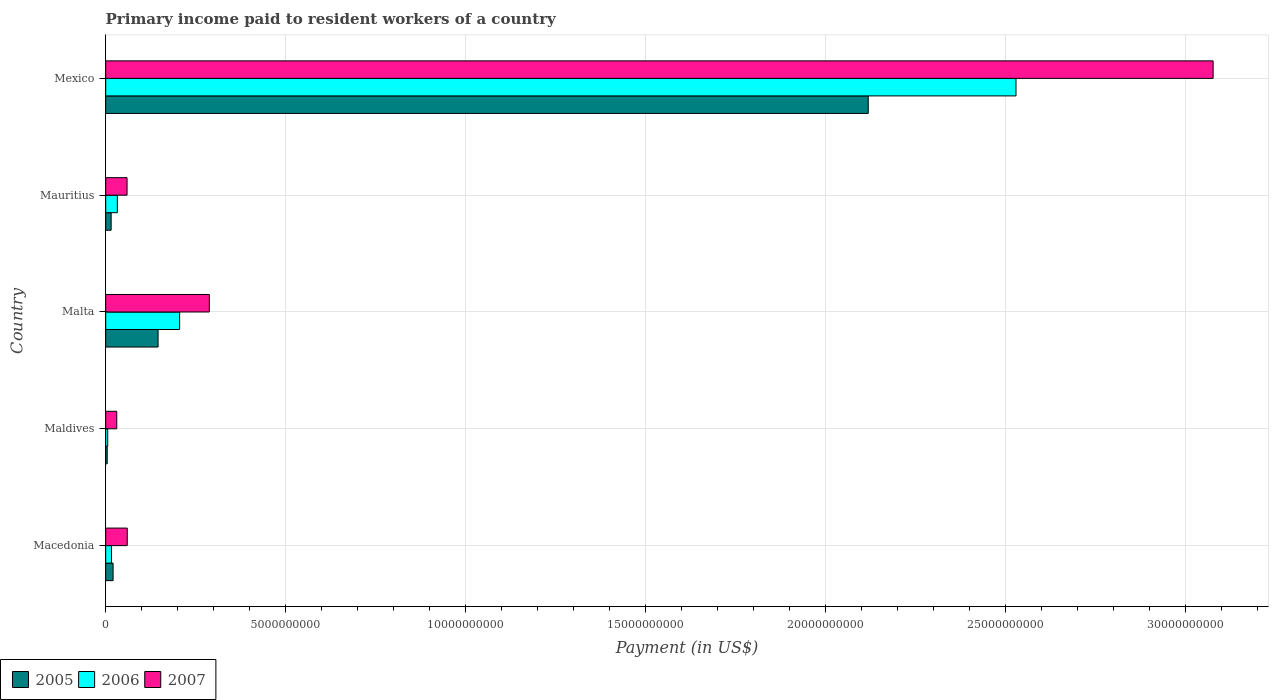How many different coloured bars are there?
Keep it short and to the point. 3. How many groups of bars are there?
Ensure brevity in your answer.  5. Are the number of bars per tick equal to the number of legend labels?
Provide a short and direct response. Yes. Are the number of bars on each tick of the Y-axis equal?
Give a very brief answer. Yes. How many bars are there on the 2nd tick from the top?
Your answer should be compact. 3. How many bars are there on the 3rd tick from the bottom?
Ensure brevity in your answer.  3. What is the label of the 4th group of bars from the top?
Provide a succinct answer. Maldives. What is the amount paid to workers in 2006 in Maldives?
Give a very brief answer. 5.63e+07. Across all countries, what is the maximum amount paid to workers in 2006?
Make the answer very short. 2.53e+1. Across all countries, what is the minimum amount paid to workers in 2007?
Your answer should be compact. 3.07e+08. In which country was the amount paid to workers in 2006 minimum?
Provide a succinct answer. Maldives. What is the total amount paid to workers in 2006 in the graph?
Provide a succinct answer. 2.79e+1. What is the difference between the amount paid to workers in 2006 in Malta and that in Mauritius?
Give a very brief answer. 1.73e+09. What is the difference between the amount paid to workers in 2005 in Malta and the amount paid to workers in 2007 in Maldives?
Provide a short and direct response. 1.15e+09. What is the average amount paid to workers in 2005 per country?
Provide a short and direct response. 4.61e+09. What is the difference between the amount paid to workers in 2007 and amount paid to workers in 2006 in Malta?
Your answer should be compact. 8.25e+08. In how many countries, is the amount paid to workers in 2005 greater than 4000000000 US$?
Ensure brevity in your answer.  1. What is the ratio of the amount paid to workers in 2007 in Macedonia to that in Malta?
Give a very brief answer. 0.21. Is the difference between the amount paid to workers in 2007 in Malta and Mexico greater than the difference between the amount paid to workers in 2006 in Malta and Mexico?
Provide a short and direct response. No. What is the difference between the highest and the second highest amount paid to workers in 2006?
Your response must be concise. 2.32e+1. What is the difference between the highest and the lowest amount paid to workers in 2006?
Keep it short and to the point. 2.52e+1. What does the 3rd bar from the bottom in Macedonia represents?
Provide a short and direct response. 2007. Are all the bars in the graph horizontal?
Provide a short and direct response. Yes. How many countries are there in the graph?
Keep it short and to the point. 5. What is the difference between two consecutive major ticks on the X-axis?
Offer a very short reply. 5.00e+09. Does the graph contain grids?
Your answer should be compact. Yes. Where does the legend appear in the graph?
Offer a terse response. Bottom left. How are the legend labels stacked?
Offer a terse response. Horizontal. What is the title of the graph?
Provide a succinct answer. Primary income paid to resident workers of a country. What is the label or title of the X-axis?
Offer a terse response. Payment (in US$). What is the Payment (in US$) of 2005 in Macedonia?
Provide a short and direct response. 2.06e+08. What is the Payment (in US$) of 2006 in Macedonia?
Your answer should be compact. 1.60e+08. What is the Payment (in US$) of 2007 in Macedonia?
Your response must be concise. 5.99e+08. What is the Payment (in US$) in 2005 in Maldives?
Offer a very short reply. 4.18e+07. What is the Payment (in US$) of 2006 in Maldives?
Provide a short and direct response. 5.63e+07. What is the Payment (in US$) of 2007 in Maldives?
Ensure brevity in your answer.  3.07e+08. What is the Payment (in US$) in 2005 in Malta?
Offer a very short reply. 1.45e+09. What is the Payment (in US$) in 2006 in Malta?
Ensure brevity in your answer.  2.05e+09. What is the Payment (in US$) in 2007 in Malta?
Make the answer very short. 2.88e+09. What is the Payment (in US$) in 2005 in Mauritius?
Make the answer very short. 1.51e+08. What is the Payment (in US$) in 2006 in Mauritius?
Make the answer very short. 3.24e+08. What is the Payment (in US$) in 2007 in Mauritius?
Provide a succinct answer. 5.93e+08. What is the Payment (in US$) of 2005 in Mexico?
Your answer should be compact. 2.12e+1. What is the Payment (in US$) of 2006 in Mexico?
Keep it short and to the point. 2.53e+1. What is the Payment (in US$) of 2007 in Mexico?
Your answer should be compact. 3.08e+1. Across all countries, what is the maximum Payment (in US$) in 2005?
Provide a succinct answer. 2.12e+1. Across all countries, what is the maximum Payment (in US$) in 2006?
Offer a terse response. 2.53e+1. Across all countries, what is the maximum Payment (in US$) in 2007?
Give a very brief answer. 3.08e+1. Across all countries, what is the minimum Payment (in US$) in 2005?
Give a very brief answer. 4.18e+07. Across all countries, what is the minimum Payment (in US$) in 2006?
Give a very brief answer. 5.63e+07. Across all countries, what is the minimum Payment (in US$) of 2007?
Your answer should be very brief. 3.07e+08. What is the total Payment (in US$) in 2005 in the graph?
Your answer should be very brief. 2.30e+1. What is the total Payment (in US$) in 2006 in the graph?
Your response must be concise. 2.79e+1. What is the total Payment (in US$) of 2007 in the graph?
Ensure brevity in your answer.  3.51e+1. What is the difference between the Payment (in US$) of 2005 in Macedonia and that in Maldives?
Provide a succinct answer. 1.64e+08. What is the difference between the Payment (in US$) of 2006 in Macedonia and that in Maldives?
Make the answer very short. 1.04e+08. What is the difference between the Payment (in US$) of 2007 in Macedonia and that in Maldives?
Provide a short and direct response. 2.91e+08. What is the difference between the Payment (in US$) in 2005 in Macedonia and that in Malta?
Provide a short and direct response. -1.25e+09. What is the difference between the Payment (in US$) in 2006 in Macedonia and that in Malta?
Ensure brevity in your answer.  -1.89e+09. What is the difference between the Payment (in US$) of 2007 in Macedonia and that in Malta?
Offer a very short reply. -2.28e+09. What is the difference between the Payment (in US$) of 2005 in Macedonia and that in Mauritius?
Offer a terse response. 5.42e+07. What is the difference between the Payment (in US$) of 2006 in Macedonia and that in Mauritius?
Offer a very short reply. -1.64e+08. What is the difference between the Payment (in US$) in 2007 in Macedonia and that in Mauritius?
Keep it short and to the point. 5.27e+06. What is the difference between the Payment (in US$) of 2005 in Macedonia and that in Mexico?
Give a very brief answer. -2.10e+1. What is the difference between the Payment (in US$) in 2006 in Macedonia and that in Mexico?
Your answer should be compact. -2.51e+1. What is the difference between the Payment (in US$) of 2007 in Macedonia and that in Mexico?
Your response must be concise. -3.02e+1. What is the difference between the Payment (in US$) of 2005 in Maldives and that in Malta?
Offer a terse response. -1.41e+09. What is the difference between the Payment (in US$) of 2006 in Maldives and that in Malta?
Offer a terse response. -2.00e+09. What is the difference between the Payment (in US$) in 2007 in Maldives and that in Malta?
Keep it short and to the point. -2.57e+09. What is the difference between the Payment (in US$) in 2005 in Maldives and that in Mauritius?
Your answer should be compact. -1.10e+08. What is the difference between the Payment (in US$) of 2006 in Maldives and that in Mauritius?
Ensure brevity in your answer.  -2.68e+08. What is the difference between the Payment (in US$) of 2007 in Maldives and that in Mauritius?
Your answer should be very brief. -2.86e+08. What is the difference between the Payment (in US$) of 2005 in Maldives and that in Mexico?
Offer a terse response. -2.11e+1. What is the difference between the Payment (in US$) of 2006 in Maldives and that in Mexico?
Ensure brevity in your answer.  -2.52e+1. What is the difference between the Payment (in US$) of 2007 in Maldives and that in Mexico?
Offer a very short reply. -3.05e+1. What is the difference between the Payment (in US$) in 2005 in Malta and that in Mauritius?
Give a very brief answer. 1.30e+09. What is the difference between the Payment (in US$) of 2006 in Malta and that in Mauritius?
Your answer should be very brief. 1.73e+09. What is the difference between the Payment (in US$) of 2007 in Malta and that in Mauritius?
Make the answer very short. 2.29e+09. What is the difference between the Payment (in US$) of 2005 in Malta and that in Mexico?
Ensure brevity in your answer.  -1.97e+1. What is the difference between the Payment (in US$) of 2006 in Malta and that in Mexico?
Your answer should be very brief. -2.32e+1. What is the difference between the Payment (in US$) in 2007 in Malta and that in Mexico?
Offer a terse response. -2.79e+1. What is the difference between the Payment (in US$) in 2005 in Mauritius and that in Mexico?
Your response must be concise. -2.10e+1. What is the difference between the Payment (in US$) of 2006 in Mauritius and that in Mexico?
Keep it short and to the point. -2.50e+1. What is the difference between the Payment (in US$) of 2007 in Mauritius and that in Mexico?
Provide a succinct answer. -3.02e+1. What is the difference between the Payment (in US$) of 2005 in Macedonia and the Payment (in US$) of 2006 in Maldives?
Keep it short and to the point. 1.49e+08. What is the difference between the Payment (in US$) in 2005 in Macedonia and the Payment (in US$) in 2007 in Maldives?
Your response must be concise. -1.02e+08. What is the difference between the Payment (in US$) in 2006 in Macedonia and the Payment (in US$) in 2007 in Maldives?
Ensure brevity in your answer.  -1.47e+08. What is the difference between the Payment (in US$) of 2005 in Macedonia and the Payment (in US$) of 2006 in Malta?
Your answer should be very brief. -1.85e+09. What is the difference between the Payment (in US$) in 2005 in Macedonia and the Payment (in US$) in 2007 in Malta?
Ensure brevity in your answer.  -2.67e+09. What is the difference between the Payment (in US$) in 2006 in Macedonia and the Payment (in US$) in 2007 in Malta?
Ensure brevity in your answer.  -2.72e+09. What is the difference between the Payment (in US$) of 2005 in Macedonia and the Payment (in US$) of 2006 in Mauritius?
Your answer should be compact. -1.18e+08. What is the difference between the Payment (in US$) of 2005 in Macedonia and the Payment (in US$) of 2007 in Mauritius?
Offer a terse response. -3.88e+08. What is the difference between the Payment (in US$) of 2006 in Macedonia and the Payment (in US$) of 2007 in Mauritius?
Offer a terse response. -4.33e+08. What is the difference between the Payment (in US$) in 2005 in Macedonia and the Payment (in US$) in 2006 in Mexico?
Your answer should be compact. -2.51e+1. What is the difference between the Payment (in US$) of 2005 in Macedonia and the Payment (in US$) of 2007 in Mexico?
Make the answer very short. -3.06e+1. What is the difference between the Payment (in US$) of 2006 in Macedonia and the Payment (in US$) of 2007 in Mexico?
Give a very brief answer. -3.06e+1. What is the difference between the Payment (in US$) of 2005 in Maldives and the Payment (in US$) of 2006 in Malta?
Make the answer very short. -2.01e+09. What is the difference between the Payment (in US$) in 2005 in Maldives and the Payment (in US$) in 2007 in Malta?
Keep it short and to the point. -2.84e+09. What is the difference between the Payment (in US$) in 2006 in Maldives and the Payment (in US$) in 2007 in Malta?
Offer a terse response. -2.82e+09. What is the difference between the Payment (in US$) of 2005 in Maldives and the Payment (in US$) of 2006 in Mauritius?
Give a very brief answer. -2.82e+08. What is the difference between the Payment (in US$) in 2005 in Maldives and the Payment (in US$) in 2007 in Mauritius?
Keep it short and to the point. -5.51e+08. What is the difference between the Payment (in US$) in 2006 in Maldives and the Payment (in US$) in 2007 in Mauritius?
Provide a short and direct response. -5.37e+08. What is the difference between the Payment (in US$) in 2005 in Maldives and the Payment (in US$) in 2006 in Mexico?
Your answer should be compact. -2.52e+1. What is the difference between the Payment (in US$) in 2005 in Maldives and the Payment (in US$) in 2007 in Mexico?
Your response must be concise. -3.07e+1. What is the difference between the Payment (in US$) in 2006 in Maldives and the Payment (in US$) in 2007 in Mexico?
Provide a succinct answer. -3.07e+1. What is the difference between the Payment (in US$) in 2005 in Malta and the Payment (in US$) in 2006 in Mauritius?
Your answer should be compact. 1.13e+09. What is the difference between the Payment (in US$) of 2005 in Malta and the Payment (in US$) of 2007 in Mauritius?
Your response must be concise. 8.62e+08. What is the difference between the Payment (in US$) in 2006 in Malta and the Payment (in US$) in 2007 in Mauritius?
Make the answer very short. 1.46e+09. What is the difference between the Payment (in US$) in 2005 in Malta and the Payment (in US$) in 2006 in Mexico?
Give a very brief answer. -2.38e+1. What is the difference between the Payment (in US$) of 2005 in Malta and the Payment (in US$) of 2007 in Mexico?
Give a very brief answer. -2.93e+1. What is the difference between the Payment (in US$) of 2006 in Malta and the Payment (in US$) of 2007 in Mexico?
Your answer should be very brief. -2.87e+1. What is the difference between the Payment (in US$) of 2005 in Mauritius and the Payment (in US$) of 2006 in Mexico?
Offer a very short reply. -2.51e+1. What is the difference between the Payment (in US$) of 2005 in Mauritius and the Payment (in US$) of 2007 in Mexico?
Provide a short and direct response. -3.06e+1. What is the difference between the Payment (in US$) of 2006 in Mauritius and the Payment (in US$) of 2007 in Mexico?
Ensure brevity in your answer.  -3.04e+1. What is the average Payment (in US$) in 2005 per country?
Your answer should be very brief. 4.61e+09. What is the average Payment (in US$) of 2006 per country?
Offer a terse response. 5.58e+09. What is the average Payment (in US$) of 2007 per country?
Provide a succinct answer. 7.03e+09. What is the difference between the Payment (in US$) in 2005 and Payment (in US$) in 2006 in Macedonia?
Offer a very short reply. 4.54e+07. What is the difference between the Payment (in US$) in 2005 and Payment (in US$) in 2007 in Macedonia?
Keep it short and to the point. -3.93e+08. What is the difference between the Payment (in US$) in 2006 and Payment (in US$) in 2007 in Macedonia?
Make the answer very short. -4.38e+08. What is the difference between the Payment (in US$) of 2005 and Payment (in US$) of 2006 in Maldives?
Keep it short and to the point. -1.45e+07. What is the difference between the Payment (in US$) in 2005 and Payment (in US$) in 2007 in Maldives?
Provide a short and direct response. -2.65e+08. What is the difference between the Payment (in US$) in 2006 and Payment (in US$) in 2007 in Maldives?
Give a very brief answer. -2.51e+08. What is the difference between the Payment (in US$) in 2005 and Payment (in US$) in 2006 in Malta?
Ensure brevity in your answer.  -5.99e+08. What is the difference between the Payment (in US$) in 2005 and Payment (in US$) in 2007 in Malta?
Ensure brevity in your answer.  -1.42e+09. What is the difference between the Payment (in US$) in 2006 and Payment (in US$) in 2007 in Malta?
Make the answer very short. -8.25e+08. What is the difference between the Payment (in US$) in 2005 and Payment (in US$) in 2006 in Mauritius?
Keep it short and to the point. -1.72e+08. What is the difference between the Payment (in US$) in 2005 and Payment (in US$) in 2007 in Mauritius?
Give a very brief answer. -4.42e+08. What is the difference between the Payment (in US$) in 2006 and Payment (in US$) in 2007 in Mauritius?
Provide a succinct answer. -2.69e+08. What is the difference between the Payment (in US$) in 2005 and Payment (in US$) in 2006 in Mexico?
Your answer should be compact. -4.10e+09. What is the difference between the Payment (in US$) of 2005 and Payment (in US$) of 2007 in Mexico?
Offer a very short reply. -9.58e+09. What is the difference between the Payment (in US$) in 2006 and Payment (in US$) in 2007 in Mexico?
Offer a very short reply. -5.48e+09. What is the ratio of the Payment (in US$) in 2005 in Macedonia to that in Maldives?
Provide a short and direct response. 4.92. What is the ratio of the Payment (in US$) of 2006 in Macedonia to that in Maldives?
Provide a short and direct response. 2.84. What is the ratio of the Payment (in US$) in 2007 in Macedonia to that in Maldives?
Your answer should be compact. 1.95. What is the ratio of the Payment (in US$) in 2005 in Macedonia to that in Malta?
Give a very brief answer. 0.14. What is the ratio of the Payment (in US$) in 2006 in Macedonia to that in Malta?
Offer a terse response. 0.08. What is the ratio of the Payment (in US$) of 2007 in Macedonia to that in Malta?
Make the answer very short. 0.21. What is the ratio of the Payment (in US$) in 2005 in Macedonia to that in Mauritius?
Provide a succinct answer. 1.36. What is the ratio of the Payment (in US$) in 2006 in Macedonia to that in Mauritius?
Make the answer very short. 0.49. What is the ratio of the Payment (in US$) in 2007 in Macedonia to that in Mauritius?
Provide a succinct answer. 1.01. What is the ratio of the Payment (in US$) in 2005 in Macedonia to that in Mexico?
Provide a succinct answer. 0.01. What is the ratio of the Payment (in US$) of 2006 in Macedonia to that in Mexico?
Offer a very short reply. 0.01. What is the ratio of the Payment (in US$) in 2007 in Macedonia to that in Mexico?
Provide a succinct answer. 0.02. What is the ratio of the Payment (in US$) of 2005 in Maldives to that in Malta?
Ensure brevity in your answer.  0.03. What is the ratio of the Payment (in US$) in 2006 in Maldives to that in Malta?
Provide a succinct answer. 0.03. What is the ratio of the Payment (in US$) of 2007 in Maldives to that in Malta?
Your answer should be compact. 0.11. What is the ratio of the Payment (in US$) of 2005 in Maldives to that in Mauritius?
Make the answer very short. 0.28. What is the ratio of the Payment (in US$) in 2006 in Maldives to that in Mauritius?
Your response must be concise. 0.17. What is the ratio of the Payment (in US$) in 2007 in Maldives to that in Mauritius?
Give a very brief answer. 0.52. What is the ratio of the Payment (in US$) in 2005 in Maldives to that in Mexico?
Provide a succinct answer. 0. What is the ratio of the Payment (in US$) in 2006 in Maldives to that in Mexico?
Provide a short and direct response. 0. What is the ratio of the Payment (in US$) in 2005 in Malta to that in Mauritius?
Make the answer very short. 9.61. What is the ratio of the Payment (in US$) in 2006 in Malta to that in Mauritius?
Offer a terse response. 6.34. What is the ratio of the Payment (in US$) of 2007 in Malta to that in Mauritius?
Your answer should be compact. 4.85. What is the ratio of the Payment (in US$) in 2005 in Malta to that in Mexico?
Offer a very short reply. 0.07. What is the ratio of the Payment (in US$) in 2006 in Malta to that in Mexico?
Provide a succinct answer. 0.08. What is the ratio of the Payment (in US$) of 2007 in Malta to that in Mexico?
Offer a very short reply. 0.09. What is the ratio of the Payment (in US$) of 2005 in Mauritius to that in Mexico?
Your response must be concise. 0.01. What is the ratio of the Payment (in US$) in 2006 in Mauritius to that in Mexico?
Provide a short and direct response. 0.01. What is the ratio of the Payment (in US$) in 2007 in Mauritius to that in Mexico?
Your answer should be compact. 0.02. What is the difference between the highest and the second highest Payment (in US$) of 2005?
Ensure brevity in your answer.  1.97e+1. What is the difference between the highest and the second highest Payment (in US$) of 2006?
Your answer should be very brief. 2.32e+1. What is the difference between the highest and the second highest Payment (in US$) in 2007?
Ensure brevity in your answer.  2.79e+1. What is the difference between the highest and the lowest Payment (in US$) in 2005?
Provide a short and direct response. 2.11e+1. What is the difference between the highest and the lowest Payment (in US$) of 2006?
Provide a short and direct response. 2.52e+1. What is the difference between the highest and the lowest Payment (in US$) of 2007?
Your answer should be very brief. 3.05e+1. 